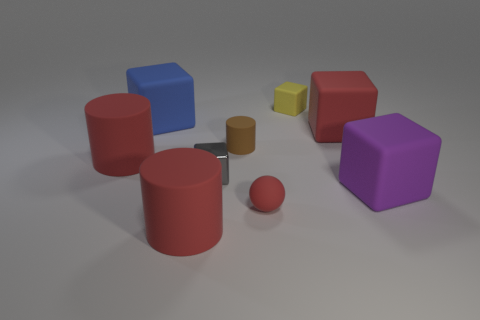Subtract all purple spheres. How many red cylinders are left? 2 Subtract all red cylinders. How many cylinders are left? 1 Add 1 matte objects. How many objects exist? 10 Subtract 1 cubes. How many cubes are left? 4 Subtract all blue cubes. How many cubes are left? 4 Subtract 0 gray spheres. How many objects are left? 9 Subtract all balls. How many objects are left? 8 Subtract all purple cylinders. Subtract all gray blocks. How many cylinders are left? 3 Subtract all tiny cubes. Subtract all tiny spheres. How many objects are left? 6 Add 1 small metallic things. How many small metallic things are left? 2 